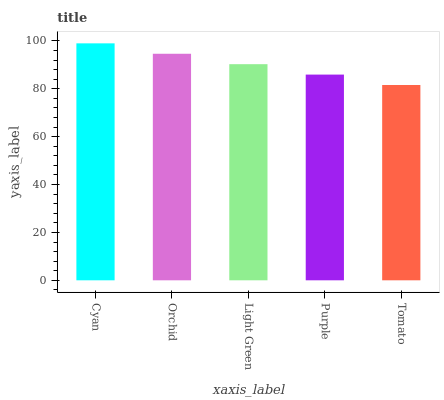Is Tomato the minimum?
Answer yes or no. Yes. Is Cyan the maximum?
Answer yes or no. Yes. Is Orchid the minimum?
Answer yes or no. No. Is Orchid the maximum?
Answer yes or no. No. Is Cyan greater than Orchid?
Answer yes or no. Yes. Is Orchid less than Cyan?
Answer yes or no. Yes. Is Orchid greater than Cyan?
Answer yes or no. No. Is Cyan less than Orchid?
Answer yes or no. No. Is Light Green the high median?
Answer yes or no. Yes. Is Light Green the low median?
Answer yes or no. Yes. Is Tomato the high median?
Answer yes or no. No. Is Purple the low median?
Answer yes or no. No. 